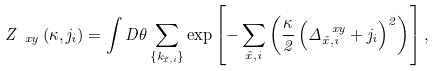Convert formula to latex. <formula><loc_0><loc_0><loc_500><loc_500>Z _ { \ x y } \left ( \kappa , j _ { i } \right ) = \int { D \theta } \sum _ { \{ k _ { \vec { x } , i } \} } \exp \left [ - \sum _ { \vec { x } , i } \left ( \frac { \kappa } { 2 } \left ( \Delta ^ { \ x y } _ { \vec { x } , i } + j _ { i } \right ) ^ { 2 } \right ) \right ] ,</formula> 